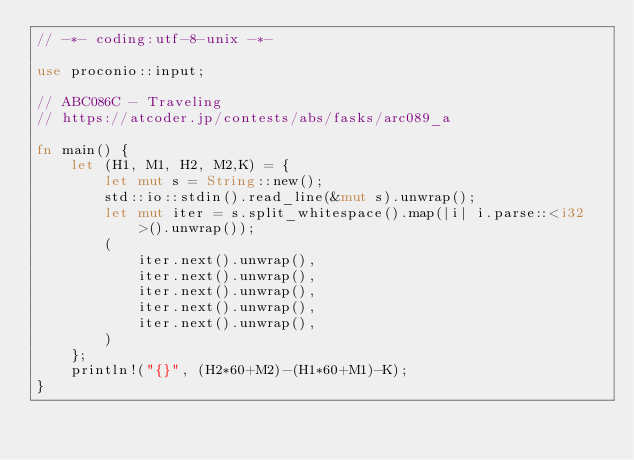Convert code to text. <code><loc_0><loc_0><loc_500><loc_500><_Rust_>// -*- coding:utf-8-unix -*-

use proconio::input;

// ABC086C - Traveling
// https://atcoder.jp/contests/abs/fasks/arc089_a

fn main() {
    let (H1, M1, H2, M2,K) = {
        let mut s = String::new();
        std::io::stdin().read_line(&mut s).unwrap();
        let mut iter = s.split_whitespace().map(|i| i.parse::<i32>().unwrap());
        (
            iter.next().unwrap(),
            iter.next().unwrap(),
            iter.next().unwrap(),
            iter.next().unwrap(),
            iter.next().unwrap(),
        )
    };
    println!("{}", (H2*60+M2)-(H1*60+M1)-K);
}</code> 